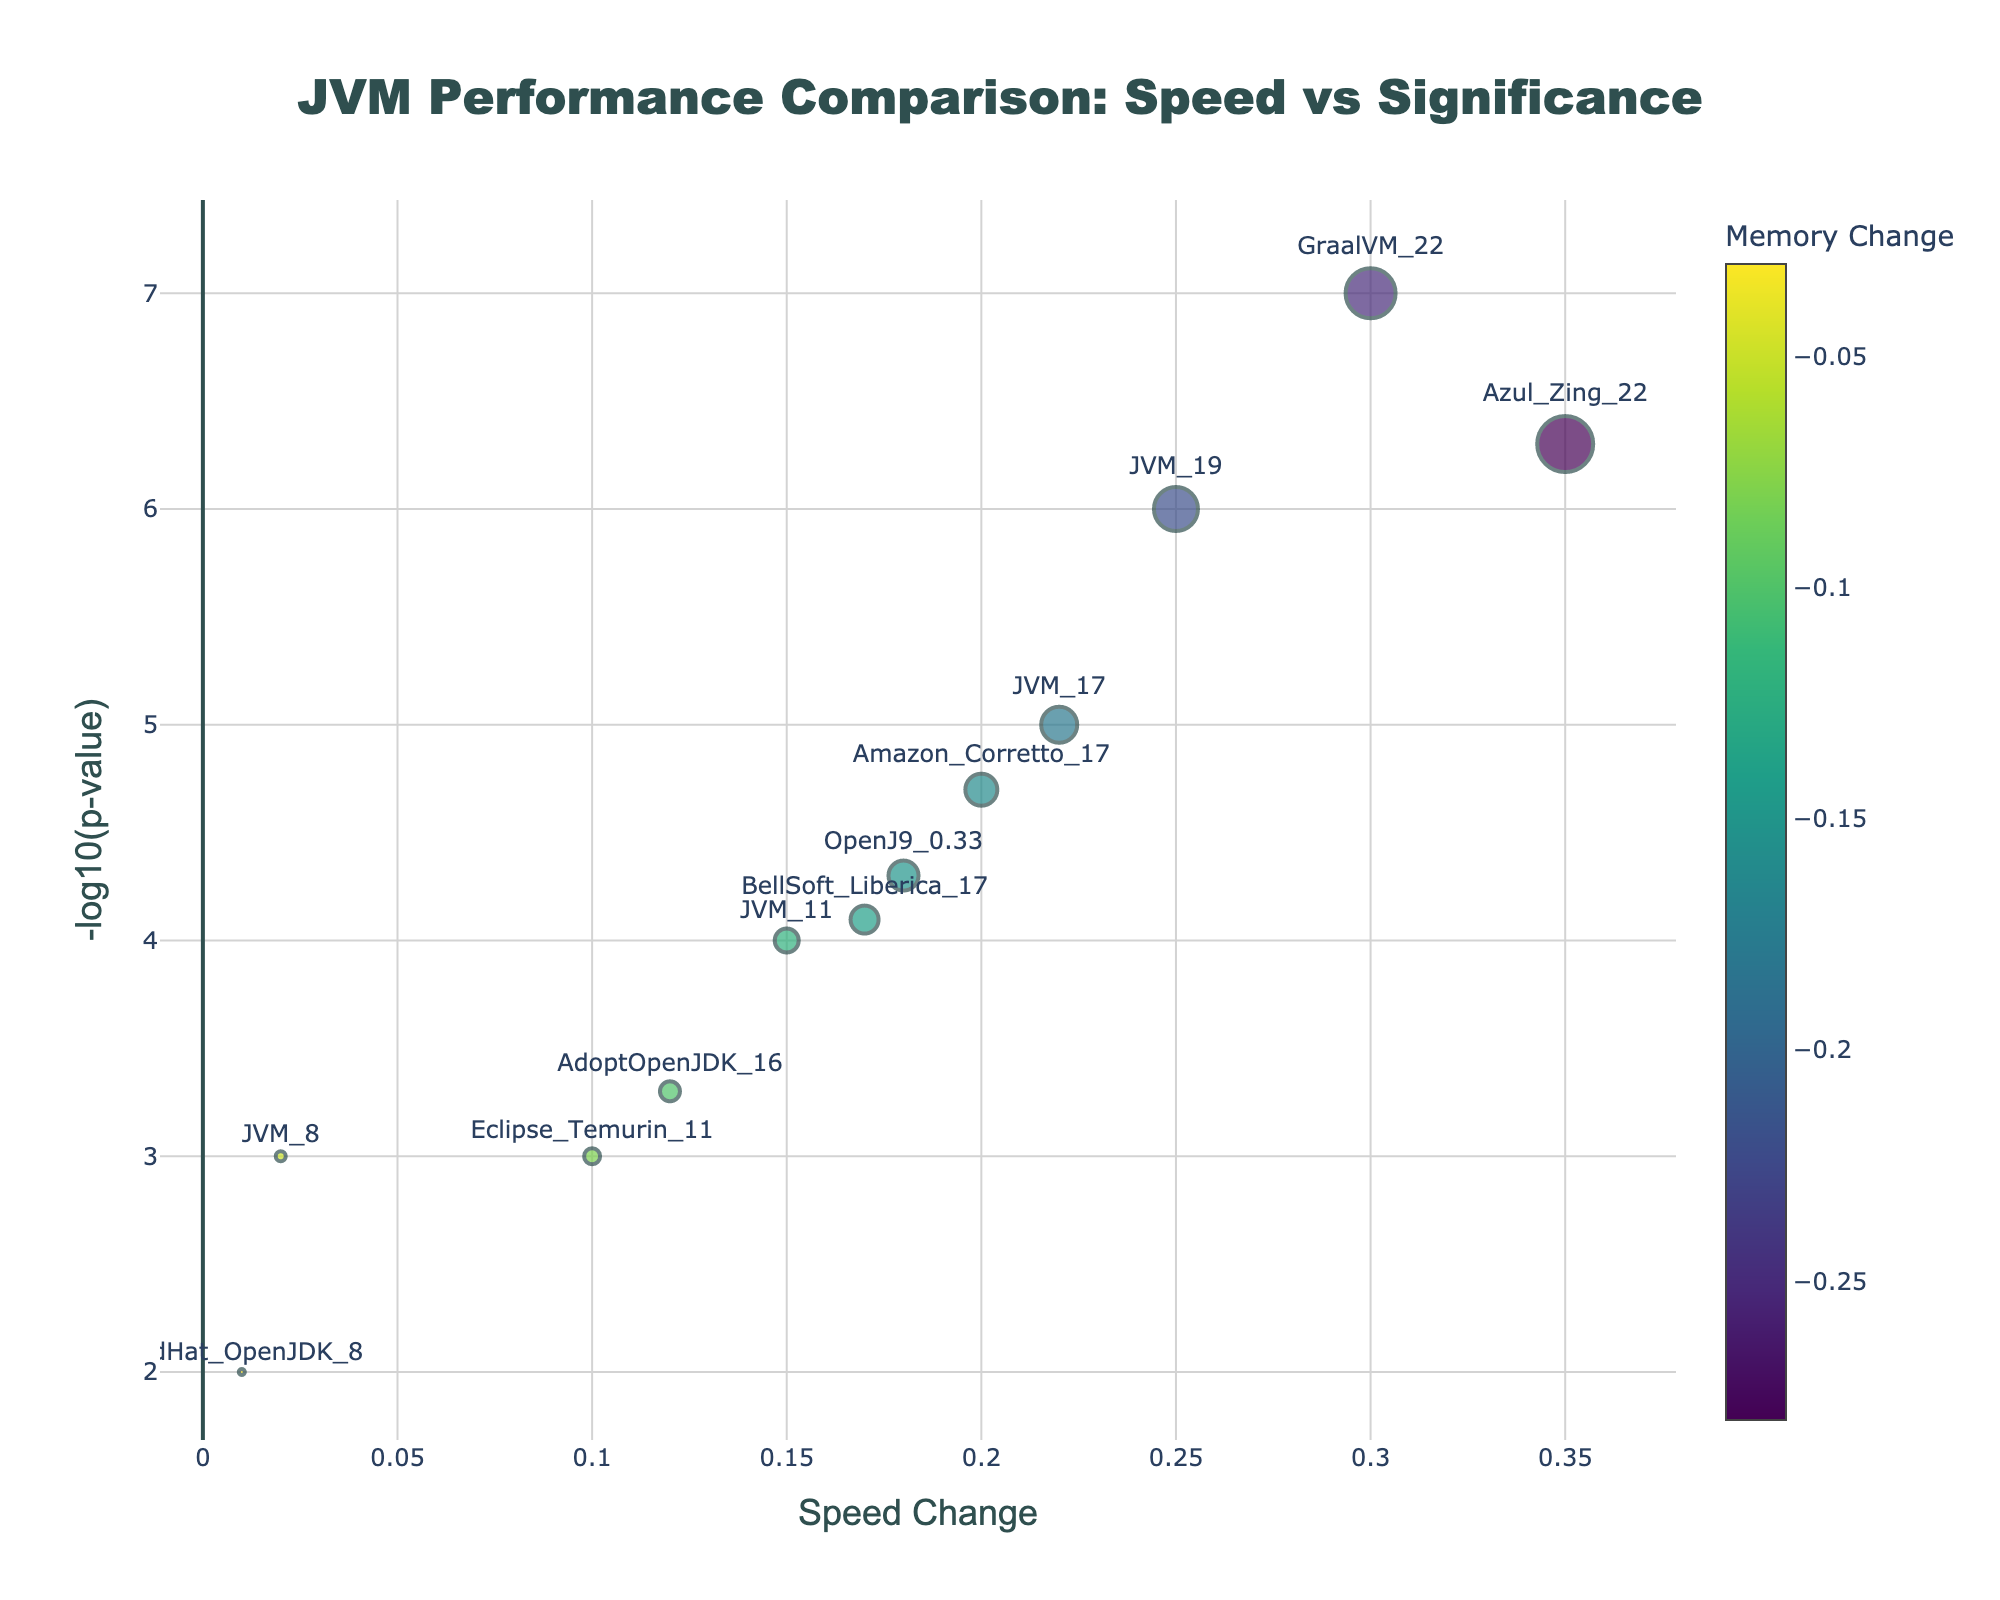What's the title of the plot? The title is usually located at the top of the plot. In this case, the plot title is "JVM Performance Comparison: Speed vs Significance".
Answer: JVM Performance Comparison: Speed vs Significance What are the labels of the x and y axes? The axis labels are typically located next to the corresponding axes. The x-axis is labeled "Speed Change", and the y-axis is labeled "-log10(p-value)".
Answer: Speed Change and -log10(p-value) Which JVM version shows the highest speed change? By looking at the x-axis, we observe which version is farthest to the right. "Azul_Zing_22" has the highest speed change of 0.35.
Answer: Azul_Zing_22 Which JVM version has the lowest memory change? The color bar indicates memory change, with colder colors representing lower values. "Azul_Zing_22" has the lowest memory change of -0.28.
Answer: Azul_Zing_22 How many data points are shown on the plot? The number of data points corresponds to the number of markers on the plot. By counting, we see there are 12 data points representing each JVM version.
Answer: 12 Which JVM version has the highest statistical significance? The highest y-value (-log10(p-value)) indicates the highest statistical significance. "GraalVM_22" is the highest on the y-axis.
Answer: GraalVM_22 What is the speed change of JVM 17? Find the marker labeled "JVM_17" and refer to the x-axis coordinate. The speed change is 0.22 for JVM_17.
Answer: 0.22 Which JVM version has both a negative memory change and a positive speed change? By observing markers with a positive x-axis (speed change) and negative color (memory change), these versions are GraalVM_22, Azul_Zing_22, JVM_19, JVM_17, Amazon_Corretto_17, BellSoft_Liberica_17, JVM_11, AdoptOpenJDK_16, and Eclipse_Temurin_11.
Answer: Several versions (List in explanation) Compare the memory change and speed change of JVM 11 and JVM 8. Which one is better in speed and memory? JVM 11 has a speed change of 0.15 and a memory change of -0.12. JVM 8 has a speed change of 0.02 and a memory change of -0.05. JVM 11 has a faster speed increase and a more significant memory reduction.
Answer: JVM 11 What is the range of the -log10(p-value) axis? The range can be found by observing the minimum and maximum values on the y-axis. The values range approximately from 2 to 7.
Answer: 2 to 7 